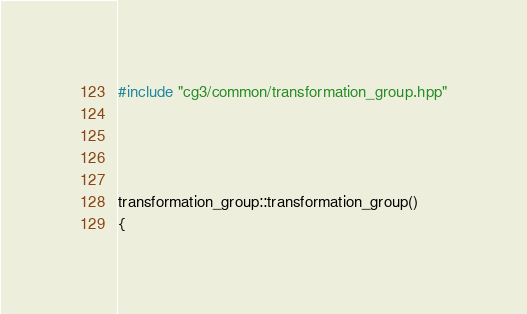Convert code to text. <code><loc_0><loc_0><loc_500><loc_500><_C++_>#include "cg3/common/transformation_group.hpp"




transformation_group::transformation_group()
{</code> 